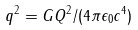Convert formula to latex. <formula><loc_0><loc_0><loc_500><loc_500>q ^ { 2 } = G Q ^ { 2 } / ( 4 \pi \epsilon _ { 0 } c ^ { 4 } )</formula> 